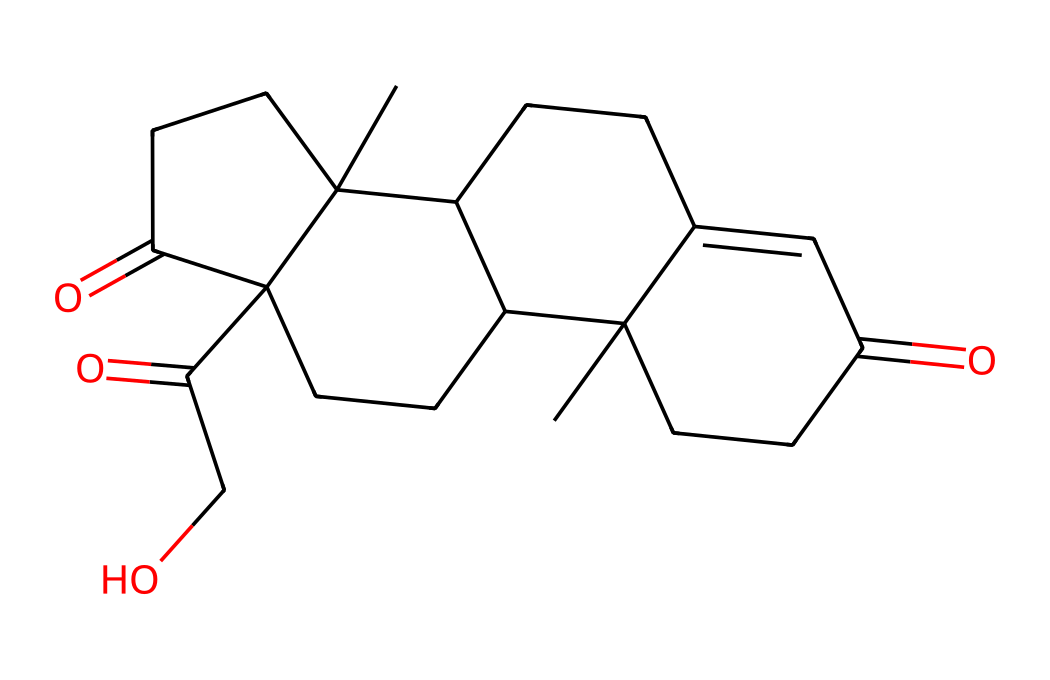What is the molecular formula of cortisol? To determine the molecular formula, we count the number of each type of atom present in the chemical structure. The SMILES representation indicates that there are 21 carbon atoms, 30 hydrogen atoms, and 5 oxygen atoms. Thus, the molecular formula is C21H30O5.
Answer: C21H30O5 How many chiral centers are present in cortisol? Chiral centers are carbon atoms bonded to four different groups. Analyzing the structure yields four such carbon atoms that have this property, indicating that cortisol has four chiral centers.
Answer: 4 What is the functional group present in cortisol? The presence of carbonyl (C=O) groups can be identified in the chemical structure based on the oxygen atom double-bonded to carbon. Cortisol has multiple carbonyl functional groups, specifically ketones and aldehydes.
Answer: carbonyl What is the significance of cortisol in biological systems? Cortisol is a hormone produced by the adrenal glands, primarily involved in the stress response and regulating various metabolic processes. It serves important roles in inflammation reduction and glucose metabolism.
Answer: stress response Which parts of the structure contribute to its lipophilicity? The long hydrocarbon chains and the presence of rings in the structure contribute to hydrophobic characteristics, making the molecule more lipophilic. Specifically, the saturated carbon atoms increase its hydrophobic nature.
Answer: hydrocarbon chains How many rings are in the cortisol structure? The structure reveals that there are four fused rings made up of carbon atoms, which is typical for steroid hormones like cortisol. Each ring can be identified by analyzing the connections in the cyclic structure.
Answer: 4 